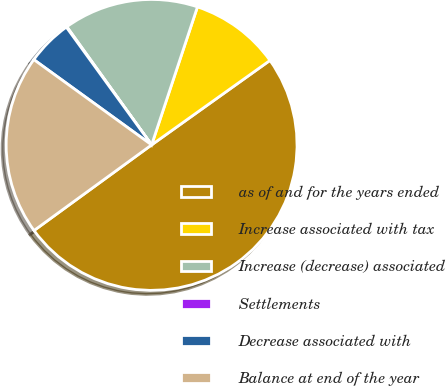Convert chart. <chart><loc_0><loc_0><loc_500><loc_500><pie_chart><fcel>as of and for the years ended<fcel>Increase associated with tax<fcel>Increase (decrease) associated<fcel>Settlements<fcel>Decrease associated with<fcel>Balance at end of the year<nl><fcel>49.85%<fcel>10.03%<fcel>15.01%<fcel>0.07%<fcel>5.05%<fcel>19.99%<nl></chart> 